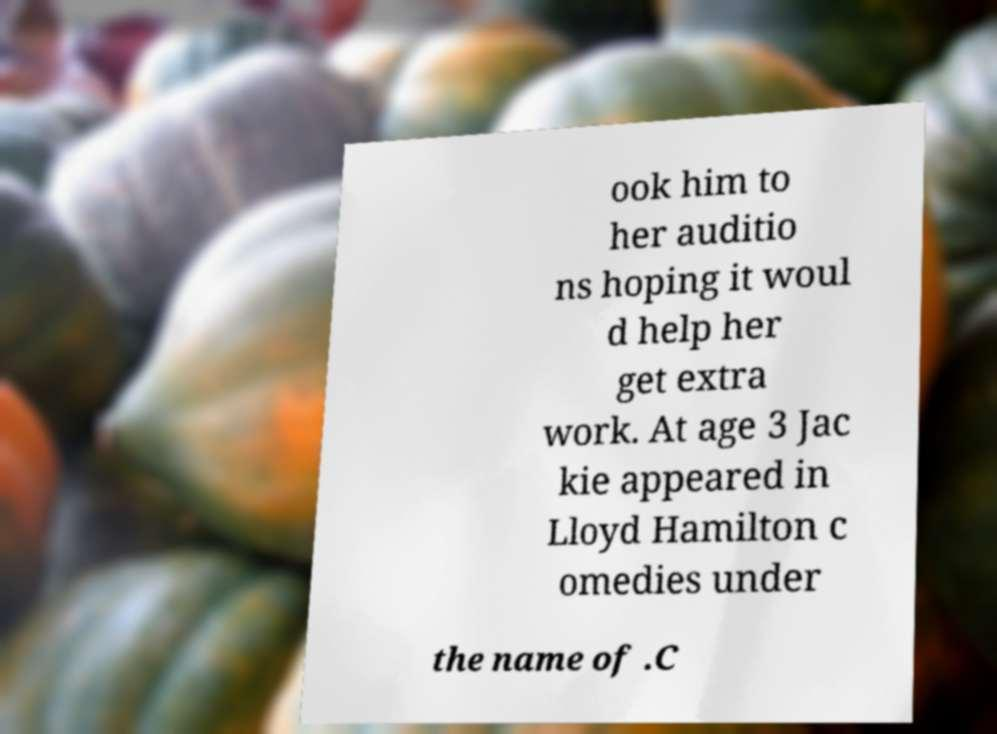Can you read and provide the text displayed in the image?This photo seems to have some interesting text. Can you extract and type it out for me? ook him to her auditio ns hoping it woul d help her get extra work. At age 3 Jac kie appeared in Lloyd Hamilton c omedies under the name of .C 